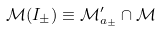Convert formula to latex. <formula><loc_0><loc_0><loc_500><loc_500>\mathcal { M } ( I _ { \pm } ) \equiv \mathcal { M } _ { a _ { \pm } } ^ { \prime } \cap \mathcal { M }</formula> 